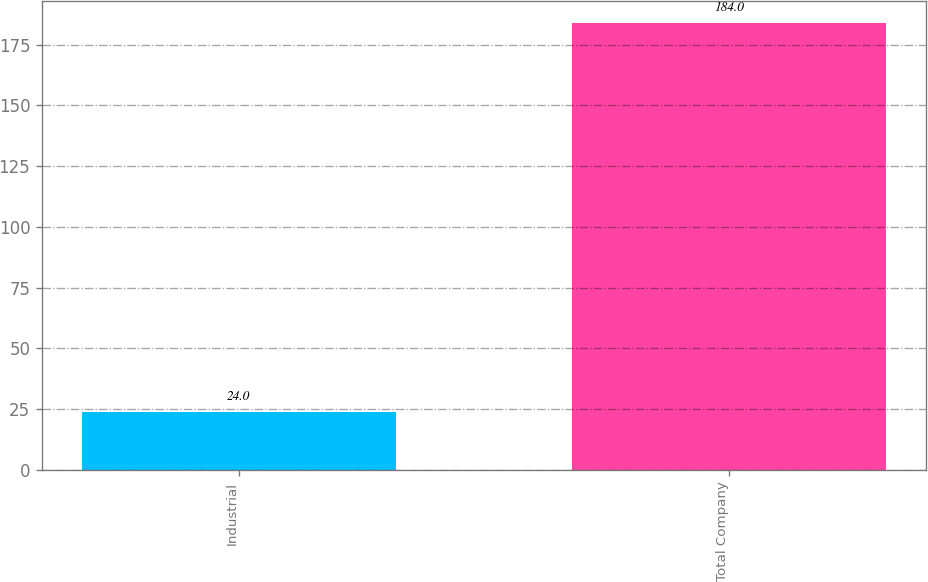Convert chart. <chart><loc_0><loc_0><loc_500><loc_500><bar_chart><fcel>Industrial<fcel>Total Company<nl><fcel>24<fcel>184<nl></chart> 